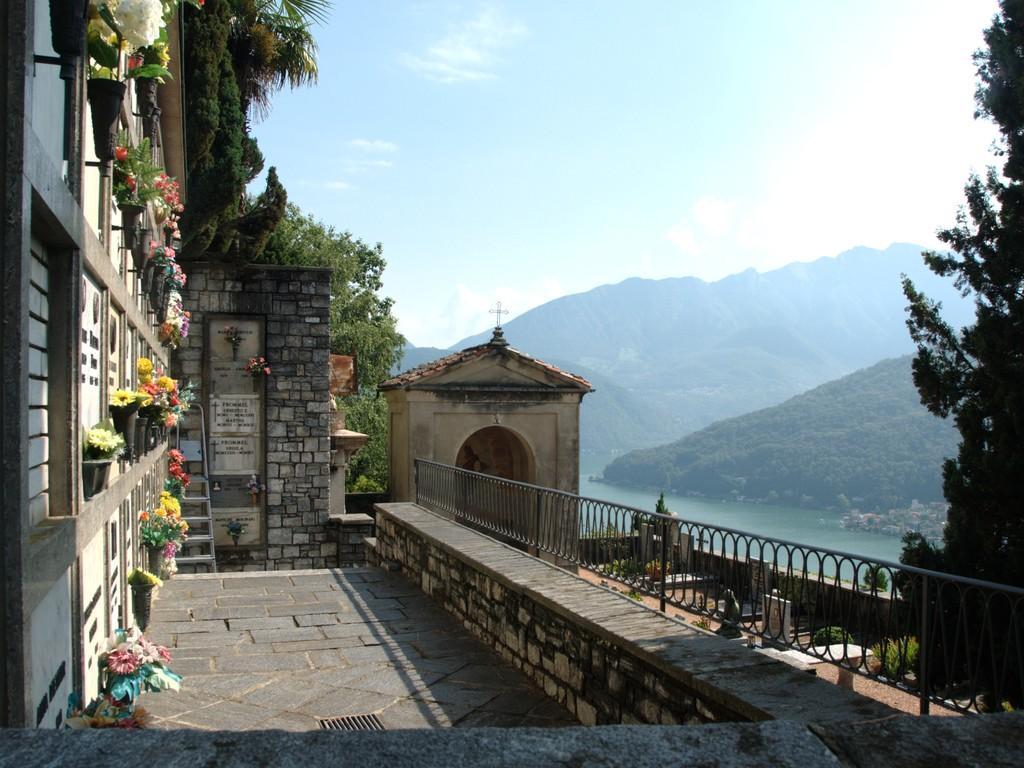In one or two sentences, can you explain what this image depicts? In this image, we can see walls, flower plants with pot, railings and trees. Here we can see few objects. Background we can see the water, hills, trees and sky. 